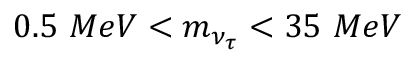Convert formula to latex. <formula><loc_0><loc_0><loc_500><loc_500>0 . 5 \ M e V < m _ { \nu _ { \tau } } < 3 5 \ M e V</formula> 